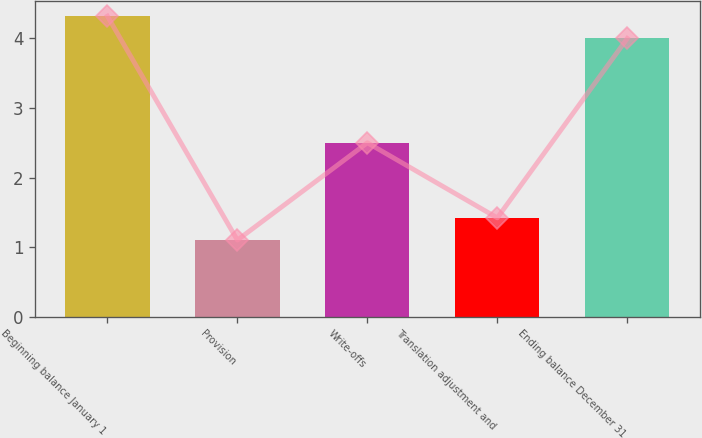Convert chart. <chart><loc_0><loc_0><loc_500><loc_500><bar_chart><fcel>Beginning balance January 1<fcel>Provision<fcel>Write-offs<fcel>Translation adjustment and<fcel>Ending balance December 31<nl><fcel>4.32<fcel>1.1<fcel>2.5<fcel>1.42<fcel>4<nl></chart> 